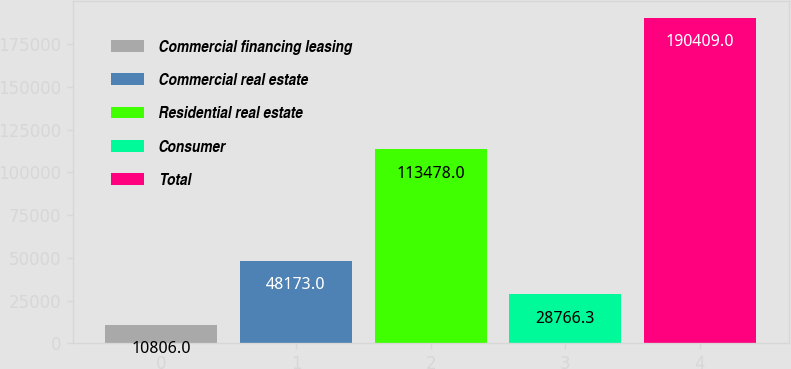Convert chart. <chart><loc_0><loc_0><loc_500><loc_500><bar_chart><fcel>Commercial financing leasing<fcel>Commercial real estate<fcel>Residential real estate<fcel>Consumer<fcel>Total<nl><fcel>10806<fcel>48173<fcel>113478<fcel>28766.3<fcel>190409<nl></chart> 